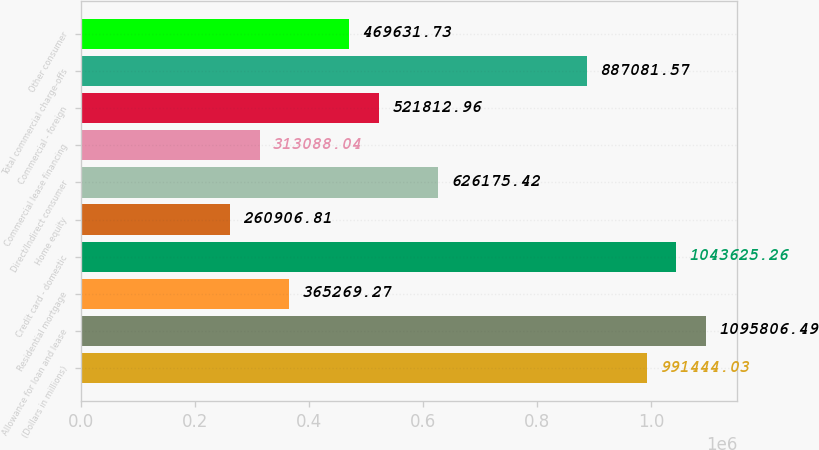<chart> <loc_0><loc_0><loc_500><loc_500><bar_chart><fcel>(Dollars in millions)<fcel>Allowance for loan and lease<fcel>Residential mortgage<fcel>Credit card - domestic<fcel>Home equity<fcel>Direct/Indirect consumer<fcel>Commercial lease financing<fcel>Commercial - foreign<fcel>Total commercial charge-offs<fcel>Other consumer<nl><fcel>991444<fcel>1.09581e+06<fcel>365269<fcel>1.04363e+06<fcel>260907<fcel>626175<fcel>313088<fcel>521813<fcel>887082<fcel>469632<nl></chart> 